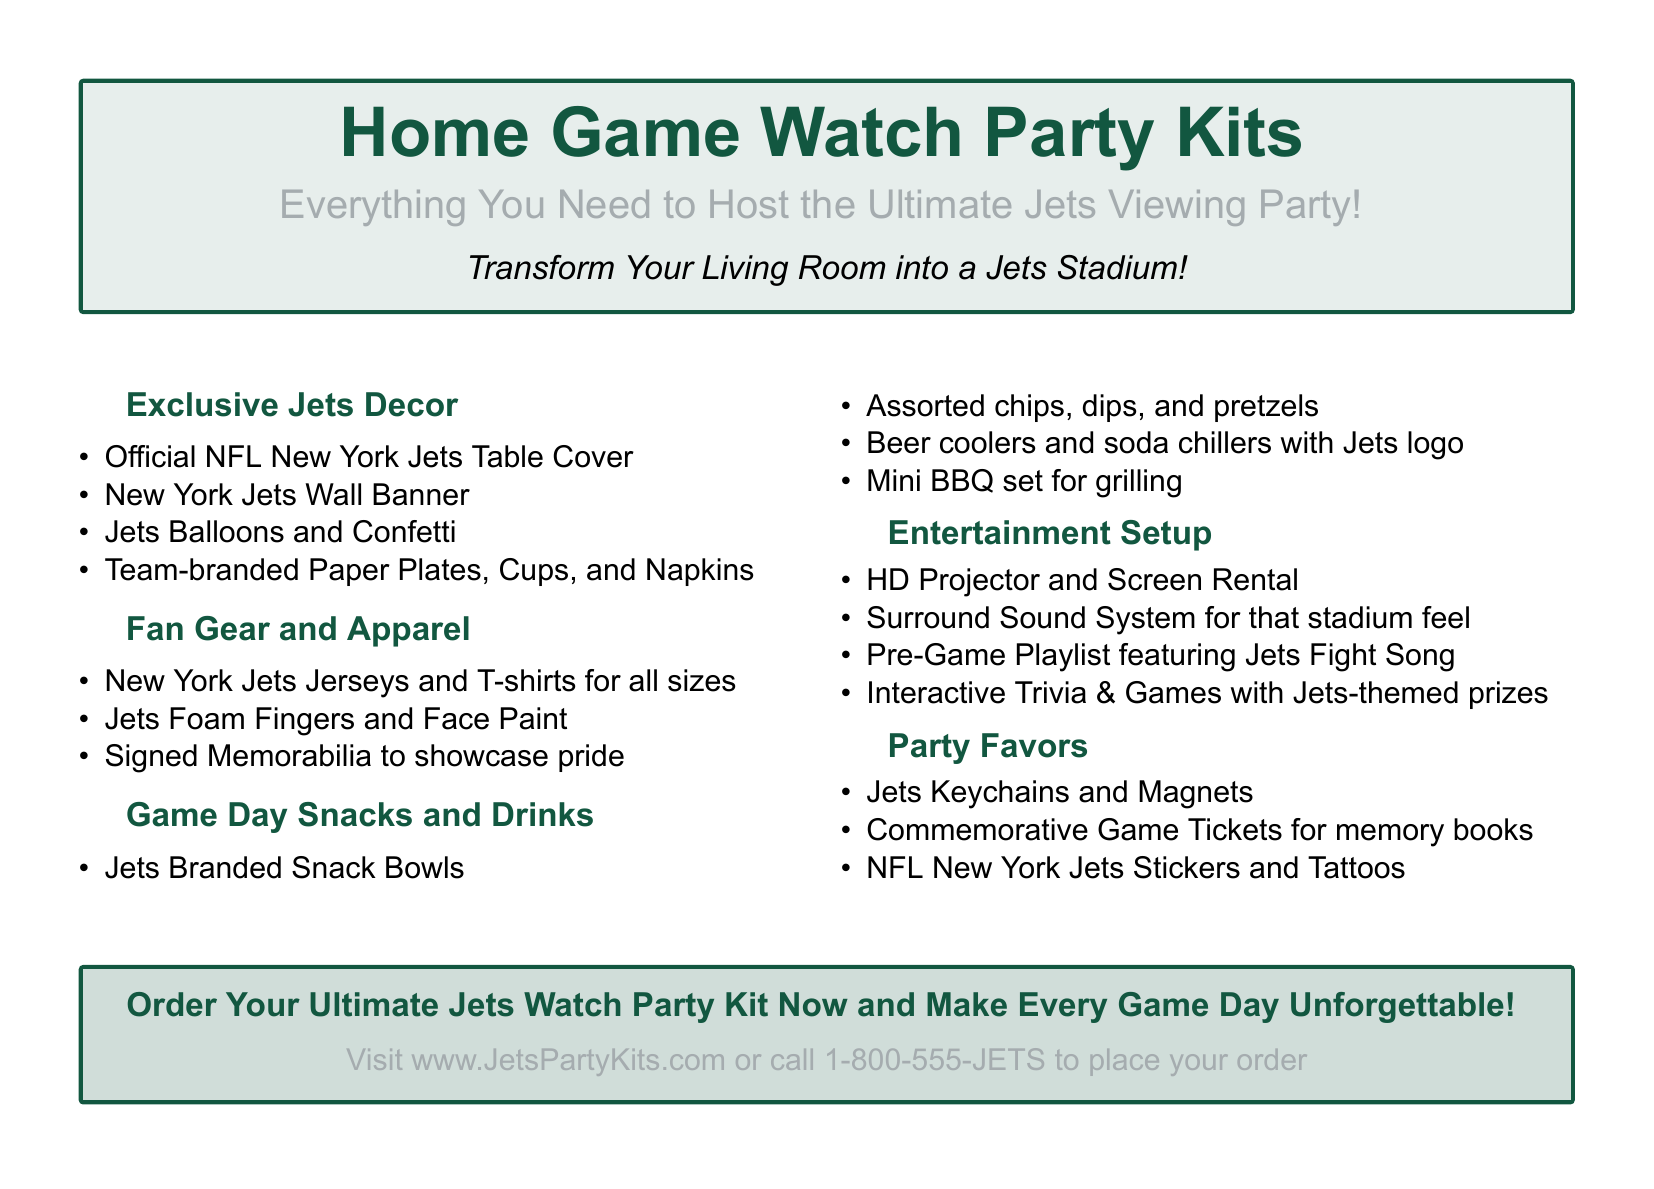What items are included in the exclusive decor? The exclusive decor section lists specific items that can be found in the document under that header.
Answer: Official NFL New York Jets Table Cover, New York Jets Wall Banner, Jets Balloons and Confetti, Team-branded Paper Plates, Cups, and Napkins What type of gear is available for fans? The fan gear section provides a list of apparel and items available for fans.
Answer: New York Jets Jerseys and T-shirts for all sizes, Jets Foam Fingers and Face Paint, Signed Memorabilia What types of snacks are mentioned in the document? The game day snacks section includes various food items listed.
Answer: Jets Branded Snack Bowls, Assorted chips, dips, and pretzels, Beer coolers and soda chillers with Jets logo, Mini BBQ set for grilling How can one order the kits? The advertisement specifies the method of ordering the kits provided in the call to action at the end.
Answer: Visit www.JetsPartyKits.com or call 1-800-555-JETS What is featured in the entertainment setup? The entertainment setup includes items and features for enhancing the game-watching experience that are listed in the relevant section.
Answer: HD Projector and Screen Rental, Surround Sound System, Pre-Game Playlist, Interactive Trivia & Games What are the party favors offered? The party favors section details small items that can be given away at the party.
Answer: Jets Keychains and Magnets, Commemorative Game Tickets, NFL New York Jets Stickers and Tattoos 